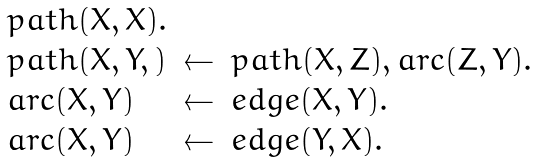Convert formula to latex. <formula><loc_0><loc_0><loc_500><loc_500>\begin{array} { l l l } p a t h ( X , X ) . \\ p a t h ( X , Y , ) & \leftarrow & p a t h ( X , Z ) , a r c ( Z , Y ) . \\ a r c ( X , Y ) & \leftarrow & e d g e ( X , Y ) . \\ a r c ( X , Y ) & \leftarrow & e d g e ( Y , X ) . \end{array}</formula> 